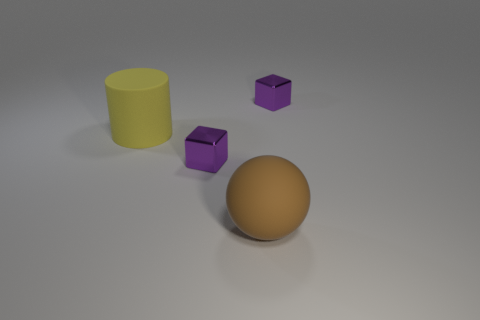There is a big yellow object left of the tiny shiny object in front of the big yellow matte object; what is its shape? The shape of the big yellow object to the left of the tiny shiny object and in front of the other big yellow matte object is a cylinder. 